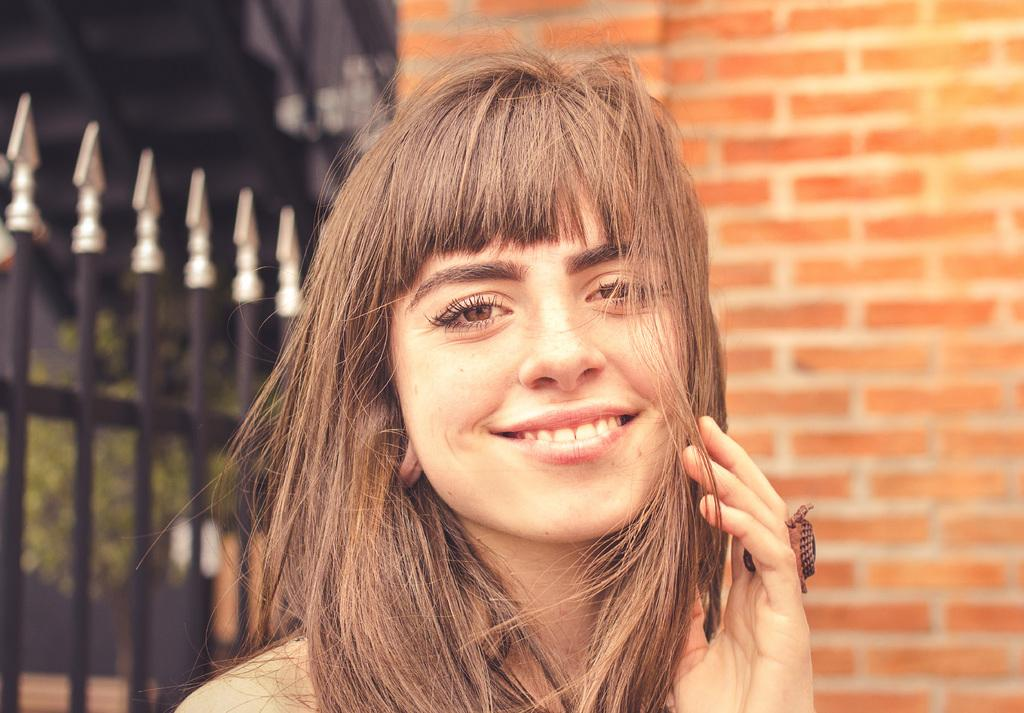Who is present in the image? There is a woman in the image. What is the woman's expression? The woman is smiling. What can be seen behind the woman? There is a wall, a fence, and plants behind the woman. What type of toy is the woman holding in the image? There is no toy present in the image; the woman is not holding anything. 